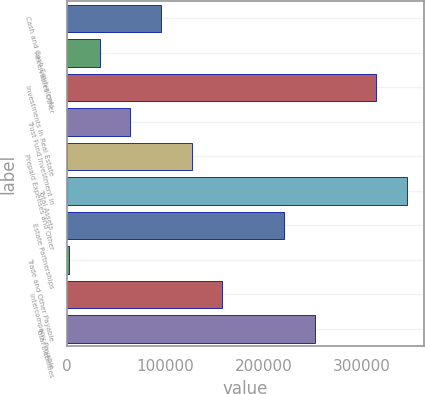Convert chart to OTSL. <chart><loc_0><loc_0><loc_500><loc_500><bar_chart><fcel>Cash and Cash Equivalents<fcel>Receivables Other<fcel>Investments in Real Estate<fcel>Trust Fund Investment in<fcel>Prepaid Expenses and Other<fcel>Total Assets<fcel>Estate Partnerships<fcel>Trade and Other Payable<fcel>Intercompany Payable<fcel>Total Liabilities<nl><fcel>95769.8<fcel>33232.6<fcel>314650<fcel>64501.2<fcel>127038<fcel>345919<fcel>220844<fcel>1964<fcel>158307<fcel>252113<nl></chart> 